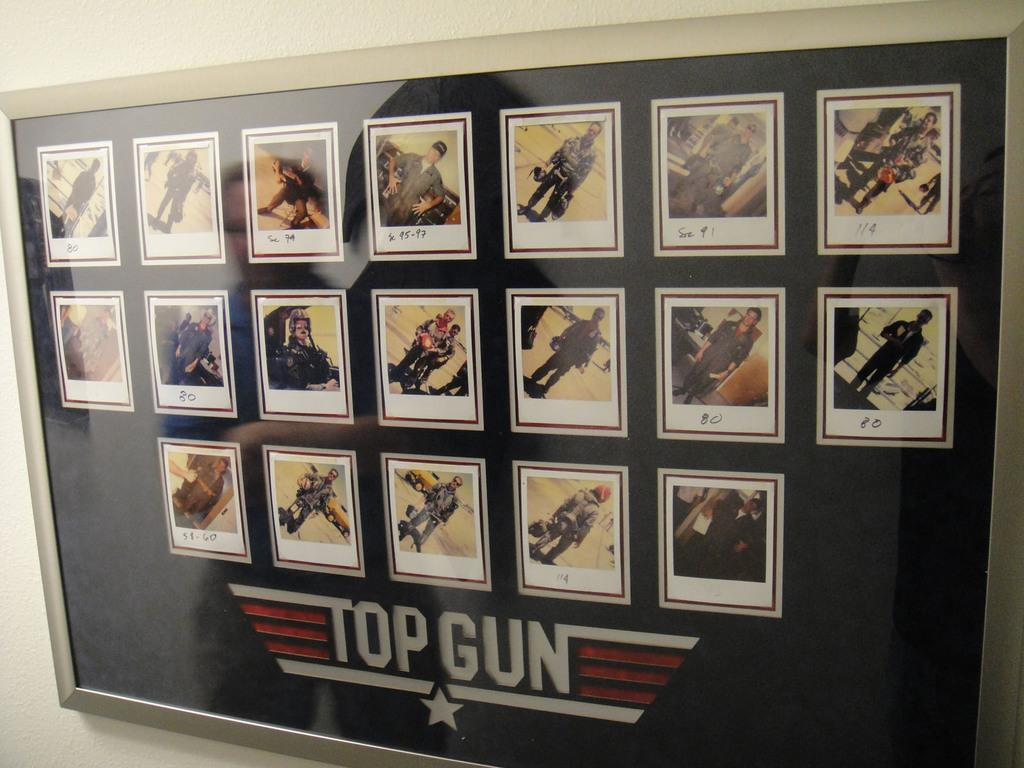<image>
Render a clear and concise summary of the photo. a large picture with the title of Top Gun 